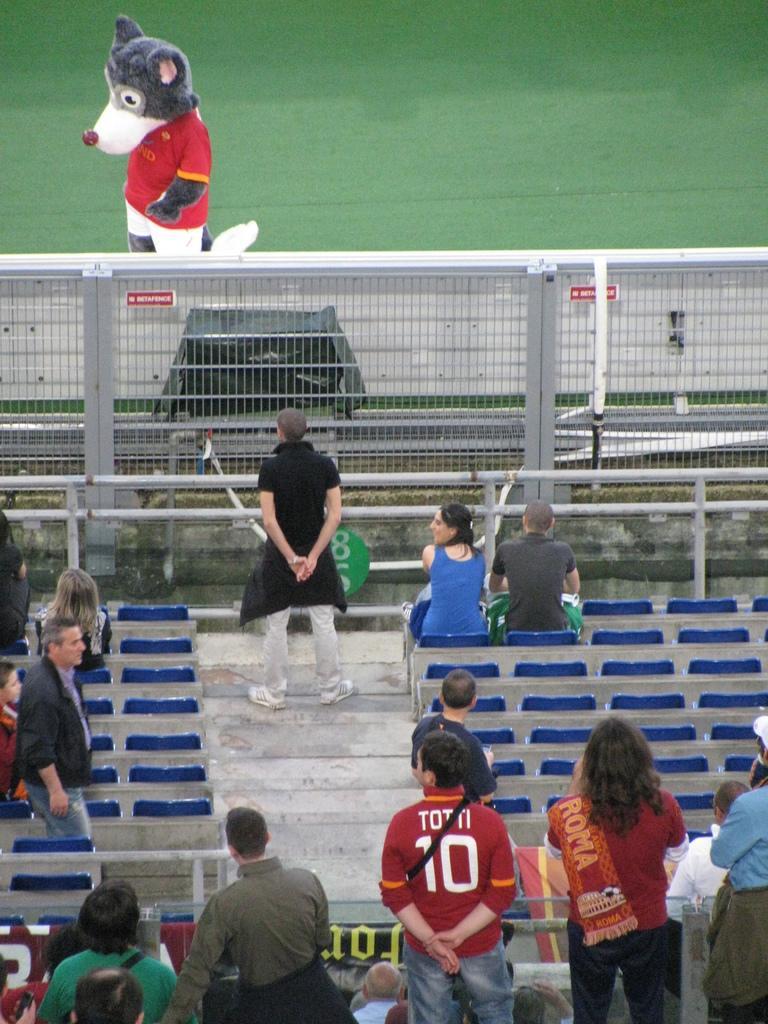Describe this image in one or two sentences. In this image I can see chairs visible in the middle and I can see some persons sitting on chairs and some persons standing in front of chair at the bottom and middle and I can see a fence visible in the middle ,at the top I can see teddy bear visible on ground. 